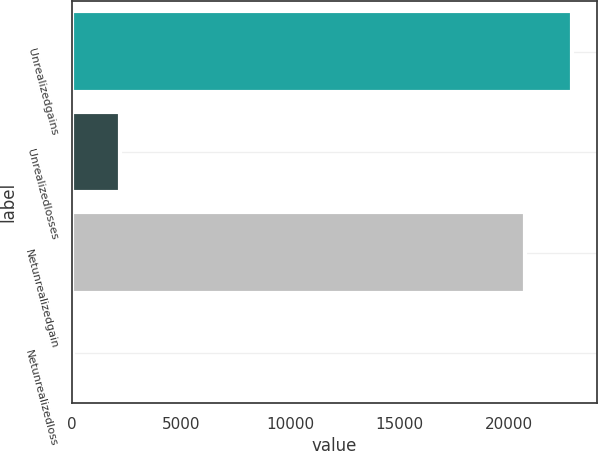Convert chart. <chart><loc_0><loc_0><loc_500><loc_500><bar_chart><fcel>Unrealizedgains<fcel>Unrealizedlosses<fcel>Netunrealizedgain<fcel>Netunrealizedloss<nl><fcel>22911.9<fcel>2224.9<fcel>20746<fcel>59<nl></chart> 